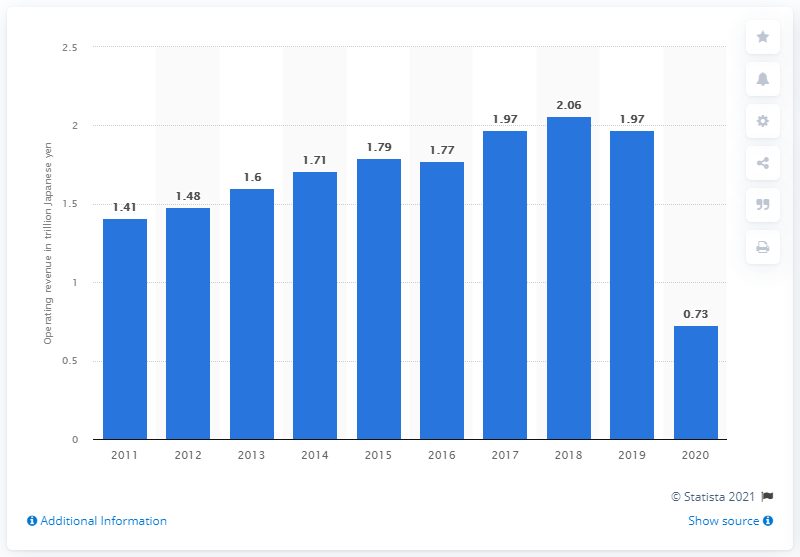Identify some key points in this picture. ANA Holdings Inc. reported an operating revenue of 0.73 billion for the period ending on March 31, 2021. ANA Holdings Inc. reported a peak revenue of 206.0 billion yen in the fiscal year 2018. 